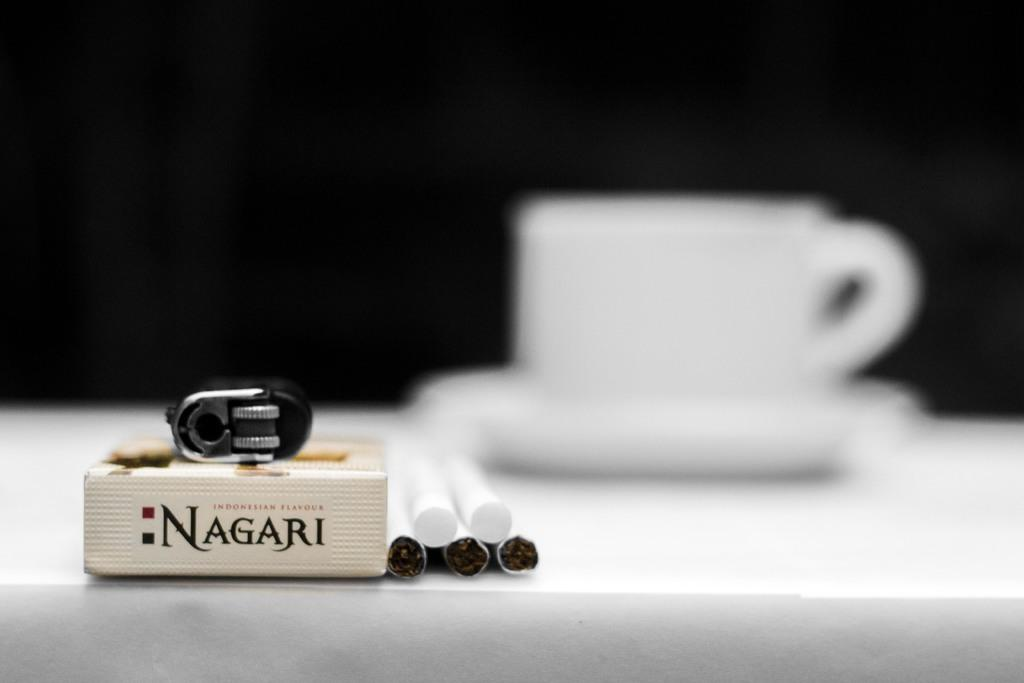What type of dishware is present in the image? There is a cup and saucer in the image. What else can be seen in the image besides the dishware? There are cigarettes and litter visible in the image. What is located on the table in the image? There is a box on the table in the image. What type of stamp can be seen on the box in the image? There is no stamp present on the box in the image. What shape is the dinner table in the image? There is no dinner table present in the image. 